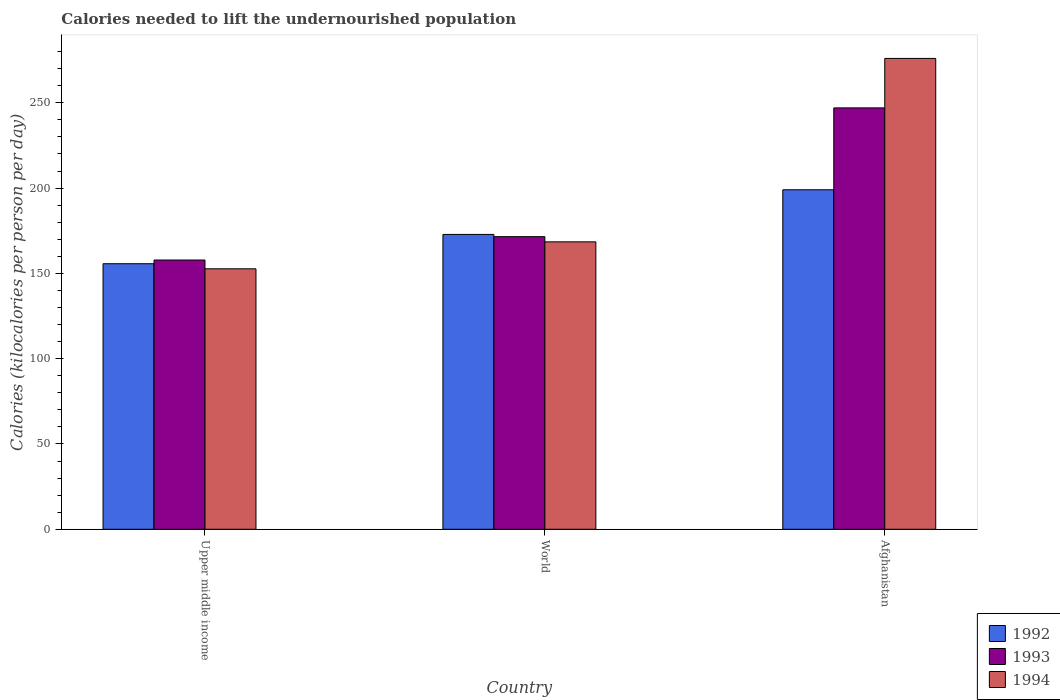How many groups of bars are there?
Your answer should be very brief. 3. Are the number of bars per tick equal to the number of legend labels?
Your answer should be very brief. Yes. What is the label of the 1st group of bars from the left?
Your answer should be compact. Upper middle income. In how many cases, is the number of bars for a given country not equal to the number of legend labels?
Your answer should be very brief. 0. What is the total calories needed to lift the undernourished population in 1992 in Afghanistan?
Your answer should be very brief. 199. Across all countries, what is the maximum total calories needed to lift the undernourished population in 1993?
Your answer should be very brief. 247. Across all countries, what is the minimum total calories needed to lift the undernourished population in 1994?
Give a very brief answer. 152.67. In which country was the total calories needed to lift the undernourished population in 1994 maximum?
Provide a succinct answer. Afghanistan. In which country was the total calories needed to lift the undernourished population in 1993 minimum?
Offer a very short reply. Upper middle income. What is the total total calories needed to lift the undernourished population in 1993 in the graph?
Your answer should be compact. 576.34. What is the difference between the total calories needed to lift the undernourished population in 1993 in Afghanistan and that in Upper middle income?
Your answer should be compact. 89.18. What is the difference between the total calories needed to lift the undernourished population in 1993 in World and the total calories needed to lift the undernourished population in 1994 in Afghanistan?
Provide a short and direct response. -104.48. What is the average total calories needed to lift the undernourished population in 1993 per country?
Keep it short and to the point. 192.11. What is the difference between the total calories needed to lift the undernourished population of/in 1992 and total calories needed to lift the undernourished population of/in 1994 in Upper middle income?
Your answer should be compact. 2.98. In how many countries, is the total calories needed to lift the undernourished population in 1993 greater than 100 kilocalories?
Ensure brevity in your answer.  3. What is the ratio of the total calories needed to lift the undernourished population in 1992 in Afghanistan to that in World?
Provide a succinct answer. 1.15. What is the difference between the highest and the second highest total calories needed to lift the undernourished population in 1994?
Your response must be concise. -107.53. What is the difference between the highest and the lowest total calories needed to lift the undernourished population in 1992?
Ensure brevity in your answer.  43.35. In how many countries, is the total calories needed to lift the undernourished population in 1994 greater than the average total calories needed to lift the undernourished population in 1994 taken over all countries?
Give a very brief answer. 1. What does the 2nd bar from the left in Upper middle income represents?
Your answer should be compact. 1993. What does the 1st bar from the right in Upper middle income represents?
Give a very brief answer. 1994. Is it the case that in every country, the sum of the total calories needed to lift the undernourished population in 1994 and total calories needed to lift the undernourished population in 1993 is greater than the total calories needed to lift the undernourished population in 1992?
Ensure brevity in your answer.  Yes. Are all the bars in the graph horizontal?
Your response must be concise. No. How many countries are there in the graph?
Provide a succinct answer. 3. Does the graph contain any zero values?
Your answer should be very brief. No. Where does the legend appear in the graph?
Make the answer very short. Bottom right. How many legend labels are there?
Offer a terse response. 3. What is the title of the graph?
Keep it short and to the point. Calories needed to lift the undernourished population. What is the label or title of the X-axis?
Provide a succinct answer. Country. What is the label or title of the Y-axis?
Your response must be concise. Calories (kilocalories per person per day). What is the Calories (kilocalories per person per day) in 1992 in Upper middle income?
Provide a succinct answer. 155.65. What is the Calories (kilocalories per person per day) of 1993 in Upper middle income?
Keep it short and to the point. 157.82. What is the Calories (kilocalories per person per day) in 1994 in Upper middle income?
Provide a succinct answer. 152.67. What is the Calories (kilocalories per person per day) in 1992 in World?
Provide a succinct answer. 172.82. What is the Calories (kilocalories per person per day) in 1993 in World?
Make the answer very short. 171.52. What is the Calories (kilocalories per person per day) of 1994 in World?
Your answer should be compact. 168.47. What is the Calories (kilocalories per person per day) of 1992 in Afghanistan?
Offer a very short reply. 199. What is the Calories (kilocalories per person per day) of 1993 in Afghanistan?
Your answer should be compact. 247. What is the Calories (kilocalories per person per day) in 1994 in Afghanistan?
Ensure brevity in your answer.  276. Across all countries, what is the maximum Calories (kilocalories per person per day) of 1992?
Your answer should be very brief. 199. Across all countries, what is the maximum Calories (kilocalories per person per day) in 1993?
Offer a very short reply. 247. Across all countries, what is the maximum Calories (kilocalories per person per day) in 1994?
Keep it short and to the point. 276. Across all countries, what is the minimum Calories (kilocalories per person per day) in 1992?
Your answer should be very brief. 155.65. Across all countries, what is the minimum Calories (kilocalories per person per day) of 1993?
Give a very brief answer. 157.82. Across all countries, what is the minimum Calories (kilocalories per person per day) in 1994?
Keep it short and to the point. 152.67. What is the total Calories (kilocalories per person per day) in 1992 in the graph?
Offer a terse response. 527.47. What is the total Calories (kilocalories per person per day) in 1993 in the graph?
Provide a short and direct response. 576.34. What is the total Calories (kilocalories per person per day) in 1994 in the graph?
Keep it short and to the point. 597.15. What is the difference between the Calories (kilocalories per person per day) of 1992 in Upper middle income and that in World?
Give a very brief answer. -17.17. What is the difference between the Calories (kilocalories per person per day) in 1993 in Upper middle income and that in World?
Your answer should be compact. -13.7. What is the difference between the Calories (kilocalories per person per day) of 1994 in Upper middle income and that in World?
Keep it short and to the point. -15.8. What is the difference between the Calories (kilocalories per person per day) in 1992 in Upper middle income and that in Afghanistan?
Ensure brevity in your answer.  -43.35. What is the difference between the Calories (kilocalories per person per day) of 1993 in Upper middle income and that in Afghanistan?
Your response must be concise. -89.18. What is the difference between the Calories (kilocalories per person per day) of 1994 in Upper middle income and that in Afghanistan?
Keep it short and to the point. -123.33. What is the difference between the Calories (kilocalories per person per day) in 1992 in World and that in Afghanistan?
Offer a very short reply. -26.18. What is the difference between the Calories (kilocalories per person per day) of 1993 in World and that in Afghanistan?
Your answer should be very brief. -75.48. What is the difference between the Calories (kilocalories per person per day) in 1994 in World and that in Afghanistan?
Make the answer very short. -107.53. What is the difference between the Calories (kilocalories per person per day) of 1992 in Upper middle income and the Calories (kilocalories per person per day) of 1993 in World?
Give a very brief answer. -15.87. What is the difference between the Calories (kilocalories per person per day) in 1992 in Upper middle income and the Calories (kilocalories per person per day) in 1994 in World?
Provide a succinct answer. -12.82. What is the difference between the Calories (kilocalories per person per day) of 1993 in Upper middle income and the Calories (kilocalories per person per day) of 1994 in World?
Ensure brevity in your answer.  -10.65. What is the difference between the Calories (kilocalories per person per day) of 1992 in Upper middle income and the Calories (kilocalories per person per day) of 1993 in Afghanistan?
Your answer should be compact. -91.35. What is the difference between the Calories (kilocalories per person per day) in 1992 in Upper middle income and the Calories (kilocalories per person per day) in 1994 in Afghanistan?
Provide a succinct answer. -120.35. What is the difference between the Calories (kilocalories per person per day) in 1993 in Upper middle income and the Calories (kilocalories per person per day) in 1994 in Afghanistan?
Your response must be concise. -118.18. What is the difference between the Calories (kilocalories per person per day) in 1992 in World and the Calories (kilocalories per person per day) in 1993 in Afghanistan?
Your answer should be very brief. -74.18. What is the difference between the Calories (kilocalories per person per day) in 1992 in World and the Calories (kilocalories per person per day) in 1994 in Afghanistan?
Provide a succinct answer. -103.18. What is the difference between the Calories (kilocalories per person per day) in 1993 in World and the Calories (kilocalories per person per day) in 1994 in Afghanistan?
Provide a succinct answer. -104.48. What is the average Calories (kilocalories per person per day) in 1992 per country?
Offer a very short reply. 175.82. What is the average Calories (kilocalories per person per day) of 1993 per country?
Provide a short and direct response. 192.11. What is the average Calories (kilocalories per person per day) of 1994 per country?
Offer a very short reply. 199.05. What is the difference between the Calories (kilocalories per person per day) in 1992 and Calories (kilocalories per person per day) in 1993 in Upper middle income?
Offer a very short reply. -2.17. What is the difference between the Calories (kilocalories per person per day) in 1992 and Calories (kilocalories per person per day) in 1994 in Upper middle income?
Your answer should be very brief. 2.98. What is the difference between the Calories (kilocalories per person per day) in 1993 and Calories (kilocalories per person per day) in 1994 in Upper middle income?
Offer a very short reply. 5.15. What is the difference between the Calories (kilocalories per person per day) in 1992 and Calories (kilocalories per person per day) in 1993 in World?
Your answer should be very brief. 1.3. What is the difference between the Calories (kilocalories per person per day) in 1992 and Calories (kilocalories per person per day) in 1994 in World?
Make the answer very short. 4.35. What is the difference between the Calories (kilocalories per person per day) in 1993 and Calories (kilocalories per person per day) in 1994 in World?
Keep it short and to the point. 3.05. What is the difference between the Calories (kilocalories per person per day) of 1992 and Calories (kilocalories per person per day) of 1993 in Afghanistan?
Offer a very short reply. -48. What is the difference between the Calories (kilocalories per person per day) of 1992 and Calories (kilocalories per person per day) of 1994 in Afghanistan?
Provide a succinct answer. -77. What is the ratio of the Calories (kilocalories per person per day) of 1992 in Upper middle income to that in World?
Provide a succinct answer. 0.9. What is the ratio of the Calories (kilocalories per person per day) in 1993 in Upper middle income to that in World?
Ensure brevity in your answer.  0.92. What is the ratio of the Calories (kilocalories per person per day) in 1994 in Upper middle income to that in World?
Provide a succinct answer. 0.91. What is the ratio of the Calories (kilocalories per person per day) of 1992 in Upper middle income to that in Afghanistan?
Your answer should be very brief. 0.78. What is the ratio of the Calories (kilocalories per person per day) of 1993 in Upper middle income to that in Afghanistan?
Provide a short and direct response. 0.64. What is the ratio of the Calories (kilocalories per person per day) in 1994 in Upper middle income to that in Afghanistan?
Provide a succinct answer. 0.55. What is the ratio of the Calories (kilocalories per person per day) of 1992 in World to that in Afghanistan?
Provide a short and direct response. 0.87. What is the ratio of the Calories (kilocalories per person per day) in 1993 in World to that in Afghanistan?
Ensure brevity in your answer.  0.69. What is the ratio of the Calories (kilocalories per person per day) of 1994 in World to that in Afghanistan?
Make the answer very short. 0.61. What is the difference between the highest and the second highest Calories (kilocalories per person per day) of 1992?
Your answer should be compact. 26.18. What is the difference between the highest and the second highest Calories (kilocalories per person per day) in 1993?
Offer a very short reply. 75.48. What is the difference between the highest and the second highest Calories (kilocalories per person per day) in 1994?
Provide a succinct answer. 107.53. What is the difference between the highest and the lowest Calories (kilocalories per person per day) of 1992?
Your answer should be compact. 43.35. What is the difference between the highest and the lowest Calories (kilocalories per person per day) of 1993?
Provide a short and direct response. 89.18. What is the difference between the highest and the lowest Calories (kilocalories per person per day) in 1994?
Your answer should be compact. 123.33. 